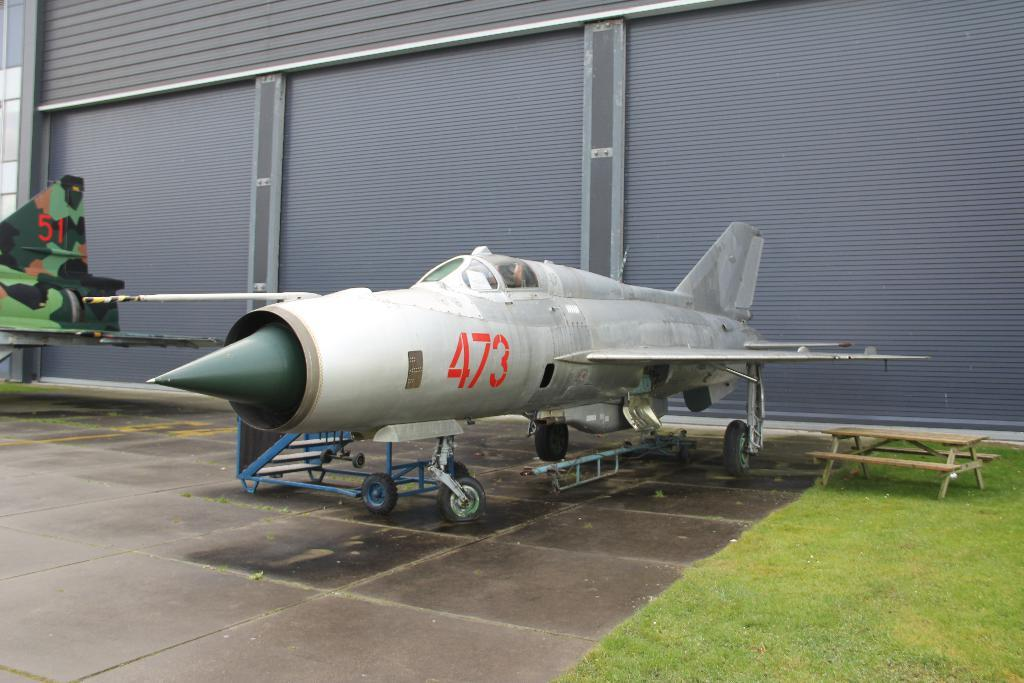What object is placed on the floor in the image? There is a plane on the floor in the image. What type of vegetation is visible to the right of the plane? There is grass to the right of the plane. Can you describe the background of the image? There are three shutters of grey color in the background of the image. What type of locket is the plane wearing in the image? There is no locket present in the image, as the plane is an inanimate object and cannot wear jewelry. 